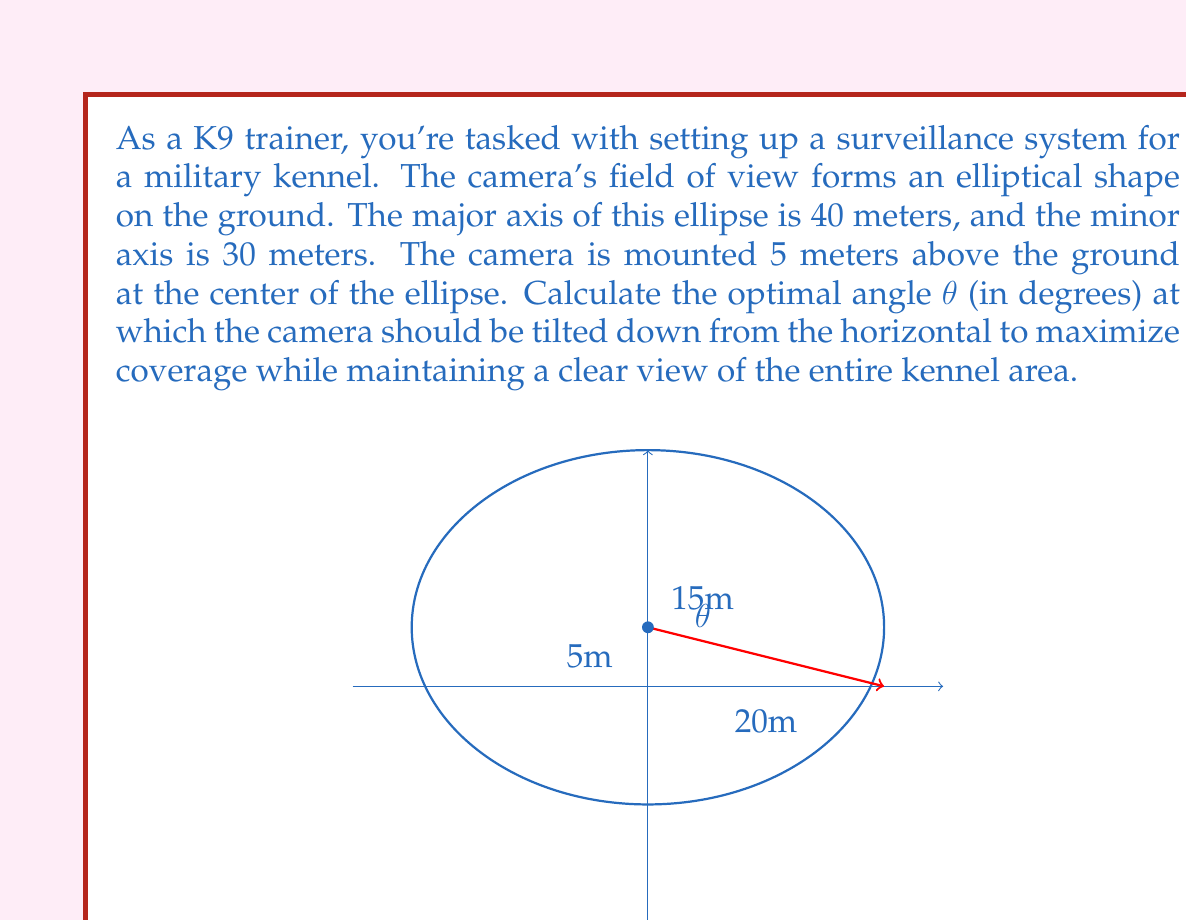Could you help me with this problem? Let's approach this step-by-step:

1) The equation of an ellipse with center (0,0) is:

   $$\frac{x^2}{a^2} + \frac{y^2}{b^2} = 1$$

   where $a$ is the semi-major axis and $b$ is the semi-minor axis.

2) In this case, $a = 20$ and $b = 15$. The camera is at point (0, 5).

3) The slope of the line from the camera to the edge of the ellipse is the tangent of the angle we're looking for. This line will be tangent to the ellipse.

4) The equation of a line through (0, 5) with slope $m$ is:

   $$y = mx + 5$$

5) Substituting this into the ellipse equation:

   $$\frac{x^2}{400} + \frac{(mx+5)^2}{225} = 1$$

6) Expanding:

   $$\frac{x^2}{400} + \frac{m^2x^2 + 10mx + 25}{225} = 1$$

7) For this line to be tangent to the ellipse, it must touch the ellipse at exactly one point. This means the quadratic equation in $x$ should have exactly one solution, which occurs when its discriminant is zero.

8) Rearranging into standard quadratic form $ax^2 + bx + c = 0$:

   $$(\frac{1}{400} + \frac{m^2}{225})x^2 + (\frac{10m}{225})x + (\frac{25}{225} - 1) = 0$$

9) For the discriminant to be zero:

   $$(\frac{10m}{225})^2 - 4(\frac{1}{400} + \frac{m^2}{225})(\frac{25}{225} - 1) = 0$$

10) Solving this equation for $m$ gives us the slope of the tangent line.

11) After simplification, we get:

    $$m = \frac{3}{4}$$

12) The angle θ is the arctangent of this slope:

    $$θ = \arctan(\frac{3}{4})$$

13) Converting to degrees:

    $$θ = \arctan(\frac{3}{4}) * \frac{180}{\pi} ≈ 36.87°$$
Answer: $36.87°$ 